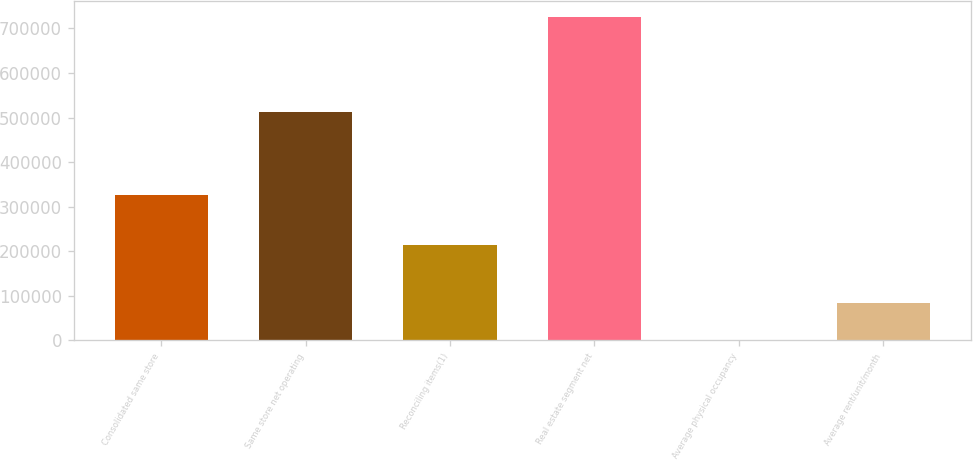Convert chart to OTSL. <chart><loc_0><loc_0><loc_500><loc_500><bar_chart><fcel>Consolidated same store<fcel>Same store net operating<fcel>Reconciling items(1)<fcel>Real estate segment net<fcel>Average physical occupancy<fcel>Average rent/unit/month<nl><fcel>325514<fcel>512234<fcel>213675<fcel>725909<fcel>94.9<fcel>83860.2<nl></chart> 